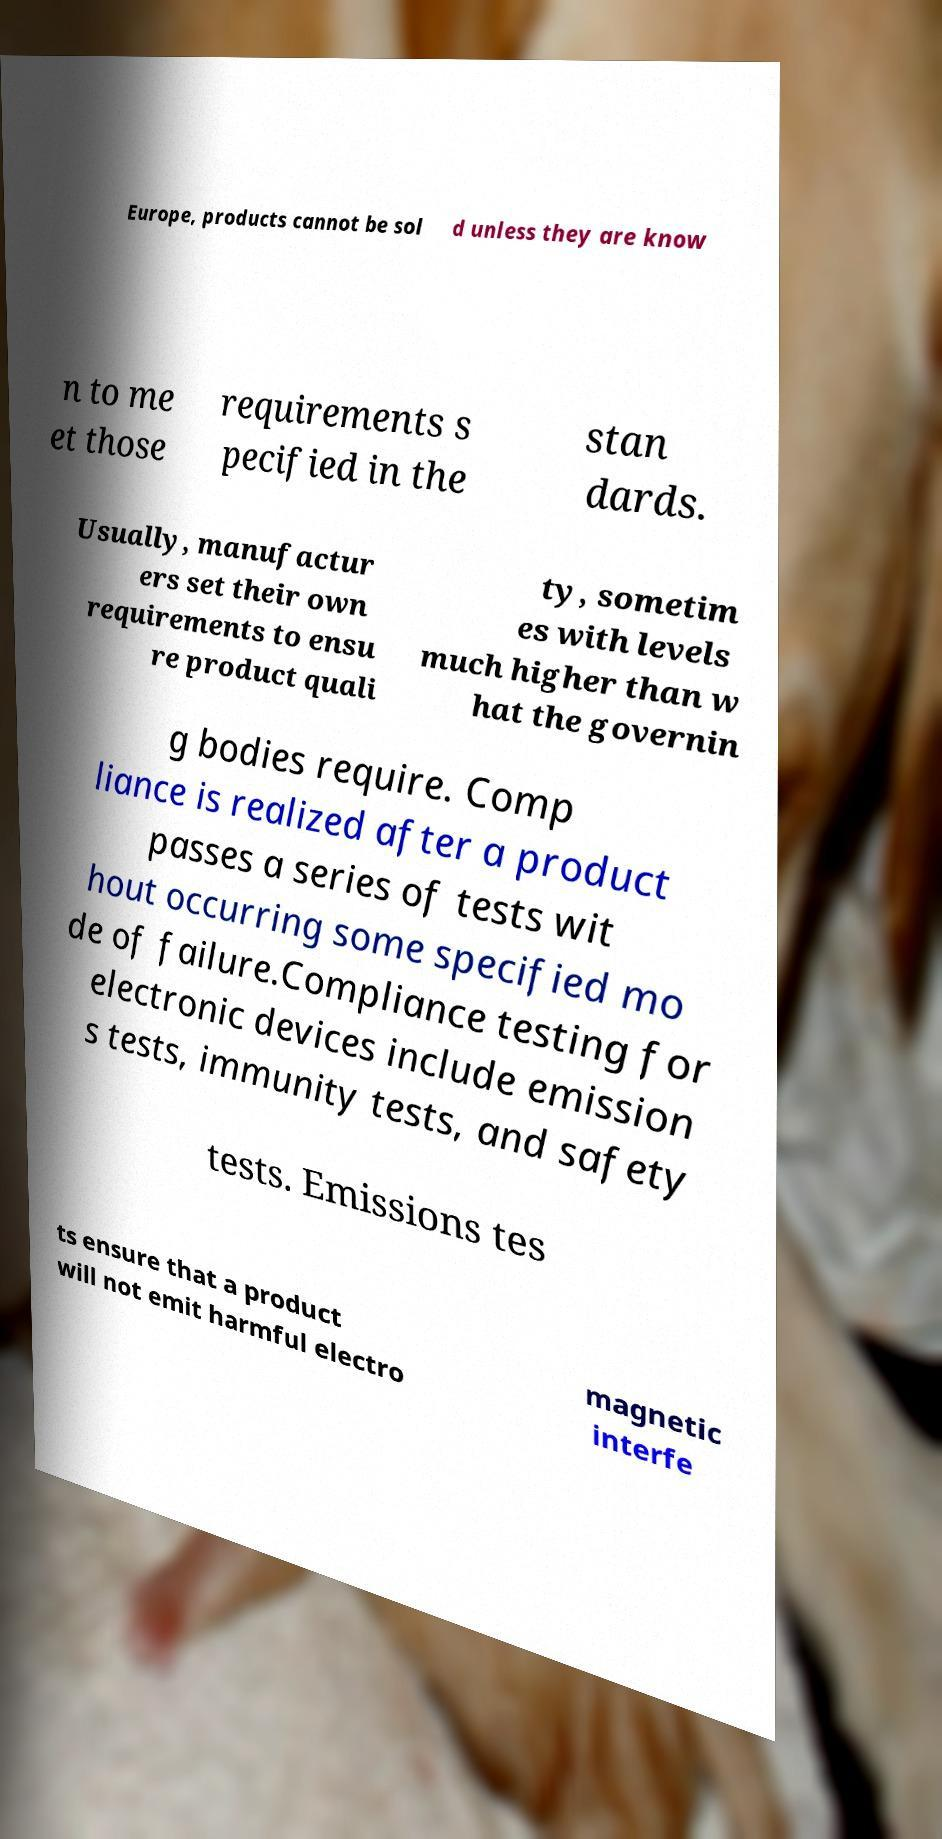Please read and relay the text visible in this image. What does it say? Europe, products cannot be sol d unless they are know n to me et those requirements s pecified in the stan dards. Usually, manufactur ers set their own requirements to ensu re product quali ty, sometim es with levels much higher than w hat the governin g bodies require. Comp liance is realized after a product passes a series of tests wit hout occurring some specified mo de of failure.Compliance testing for electronic devices include emission s tests, immunity tests, and safety tests. Emissions tes ts ensure that a product will not emit harmful electro magnetic interfe 